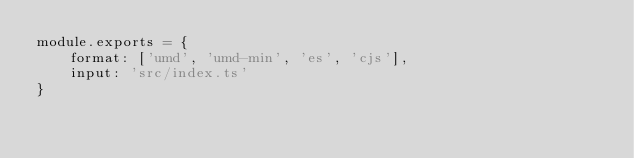Convert code to text. <code><loc_0><loc_0><loc_500><loc_500><_JavaScript_>module.exports = {
	format: ['umd', 'umd-min', 'es', 'cjs'],
	input: 'src/index.ts'
}
</code> 